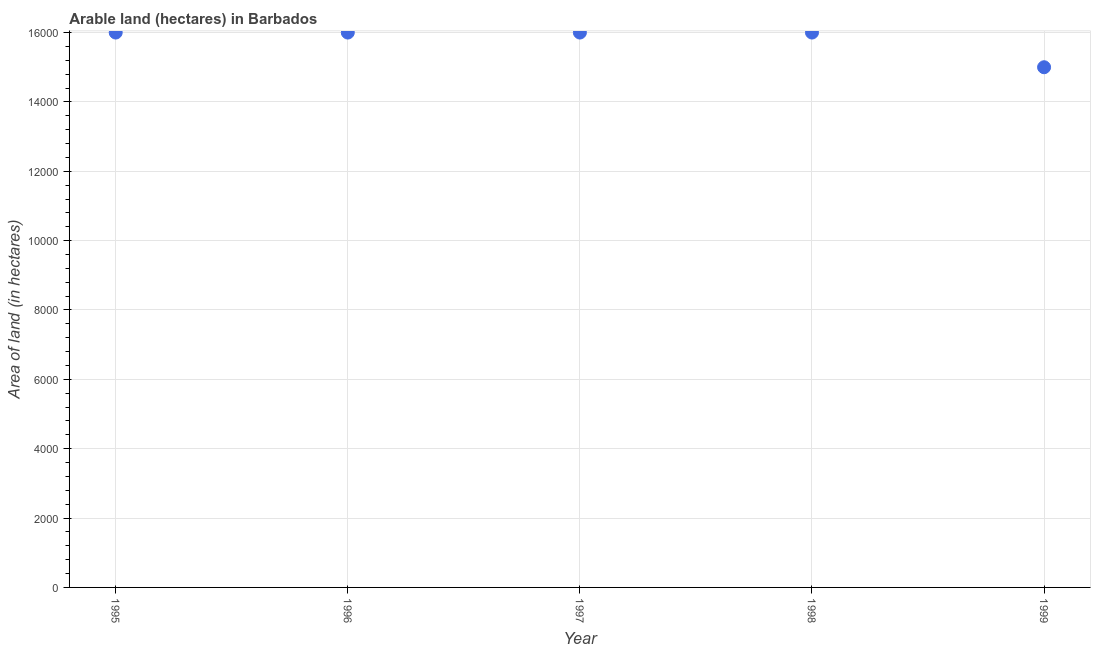What is the area of land in 1996?
Offer a very short reply. 1.60e+04. Across all years, what is the maximum area of land?
Provide a succinct answer. 1.60e+04. Across all years, what is the minimum area of land?
Provide a short and direct response. 1.50e+04. In which year was the area of land maximum?
Offer a terse response. 1995. What is the sum of the area of land?
Your answer should be very brief. 7.90e+04. What is the difference between the area of land in 1995 and 1996?
Make the answer very short. 0. What is the average area of land per year?
Offer a terse response. 1.58e+04. What is the median area of land?
Provide a succinct answer. 1.60e+04. In how many years, is the area of land greater than 3600 hectares?
Give a very brief answer. 5. Is the area of land in 1996 less than that in 1998?
Give a very brief answer. No. What is the difference between the highest and the lowest area of land?
Your answer should be very brief. 1000. Does the area of land monotonically increase over the years?
Give a very brief answer. No. How many dotlines are there?
Your answer should be compact. 1. How many years are there in the graph?
Your answer should be very brief. 5. What is the difference between two consecutive major ticks on the Y-axis?
Offer a terse response. 2000. Does the graph contain any zero values?
Your answer should be very brief. No. Does the graph contain grids?
Ensure brevity in your answer.  Yes. What is the title of the graph?
Offer a terse response. Arable land (hectares) in Barbados. What is the label or title of the X-axis?
Make the answer very short. Year. What is the label or title of the Y-axis?
Provide a succinct answer. Area of land (in hectares). What is the Area of land (in hectares) in 1995?
Make the answer very short. 1.60e+04. What is the Area of land (in hectares) in 1996?
Make the answer very short. 1.60e+04. What is the Area of land (in hectares) in 1997?
Offer a very short reply. 1.60e+04. What is the Area of land (in hectares) in 1998?
Your answer should be very brief. 1.60e+04. What is the Area of land (in hectares) in 1999?
Make the answer very short. 1.50e+04. What is the difference between the Area of land (in hectares) in 1995 and 1997?
Offer a terse response. 0. What is the difference between the Area of land (in hectares) in 1995 and 1998?
Offer a very short reply. 0. What is the difference between the Area of land (in hectares) in 1996 and 1997?
Ensure brevity in your answer.  0. What is the difference between the Area of land (in hectares) in 1996 and 1998?
Offer a terse response. 0. What is the difference between the Area of land (in hectares) in 1996 and 1999?
Give a very brief answer. 1000. What is the difference between the Area of land (in hectares) in 1997 and 1998?
Keep it short and to the point. 0. What is the ratio of the Area of land (in hectares) in 1995 to that in 1998?
Give a very brief answer. 1. What is the ratio of the Area of land (in hectares) in 1995 to that in 1999?
Give a very brief answer. 1.07. What is the ratio of the Area of land (in hectares) in 1996 to that in 1998?
Offer a very short reply. 1. What is the ratio of the Area of land (in hectares) in 1996 to that in 1999?
Offer a very short reply. 1.07. What is the ratio of the Area of land (in hectares) in 1997 to that in 1998?
Provide a succinct answer. 1. What is the ratio of the Area of land (in hectares) in 1997 to that in 1999?
Give a very brief answer. 1.07. What is the ratio of the Area of land (in hectares) in 1998 to that in 1999?
Ensure brevity in your answer.  1.07. 